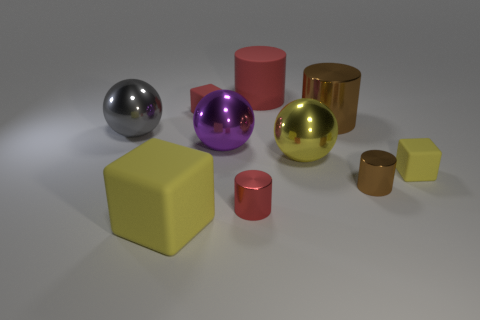What number of rubber things are either purple objects or red blocks?
Your answer should be very brief. 1. Are there any brown rubber blocks of the same size as the purple shiny ball?
Keep it short and to the point. No. Is the number of metal things that are to the right of the big yellow sphere greater than the number of small green blocks?
Provide a succinct answer. Yes. What number of large objects are yellow objects or blue shiny balls?
Your answer should be very brief. 2. How many purple things are the same shape as the big gray thing?
Make the answer very short. 1. What material is the small cube to the left of the tiny red thing on the right side of the small red rubber object?
Offer a terse response. Rubber. There is a rubber cube to the right of the tiny red metal cylinder; how big is it?
Give a very brief answer. Small. How many blue objects are either small cubes or large things?
Your response must be concise. 0. What is the material of the tiny red thing that is the same shape as the small brown metallic thing?
Keep it short and to the point. Metal. Is the number of big purple metallic objects on the left side of the red cube the same as the number of red cylinders?
Provide a short and direct response. No. 